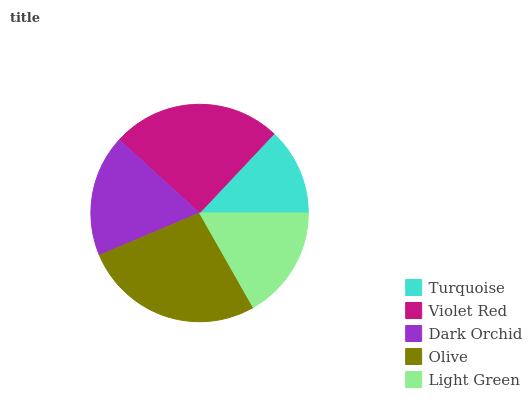Is Turquoise the minimum?
Answer yes or no. Yes. Is Olive the maximum?
Answer yes or no. Yes. Is Violet Red the minimum?
Answer yes or no. No. Is Violet Red the maximum?
Answer yes or no. No. Is Violet Red greater than Turquoise?
Answer yes or no. Yes. Is Turquoise less than Violet Red?
Answer yes or no. Yes. Is Turquoise greater than Violet Red?
Answer yes or no. No. Is Violet Red less than Turquoise?
Answer yes or no. No. Is Dark Orchid the high median?
Answer yes or no. Yes. Is Dark Orchid the low median?
Answer yes or no. Yes. Is Olive the high median?
Answer yes or no. No. Is Turquoise the low median?
Answer yes or no. No. 